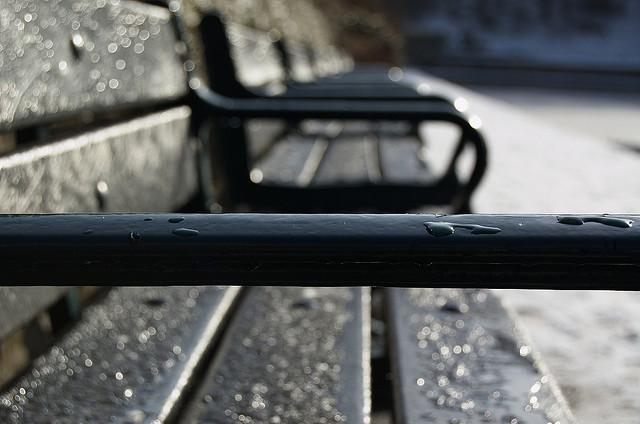Has it rained recently here?
Answer briefly. Yes. Is there mold on the bench?
Short answer required. No. What is the bench made of?
Answer briefly. Wood. Will the sun comes out soon to dry the benches?
Answer briefly. Yes. What color is the bench?
Write a very short answer. Black. 